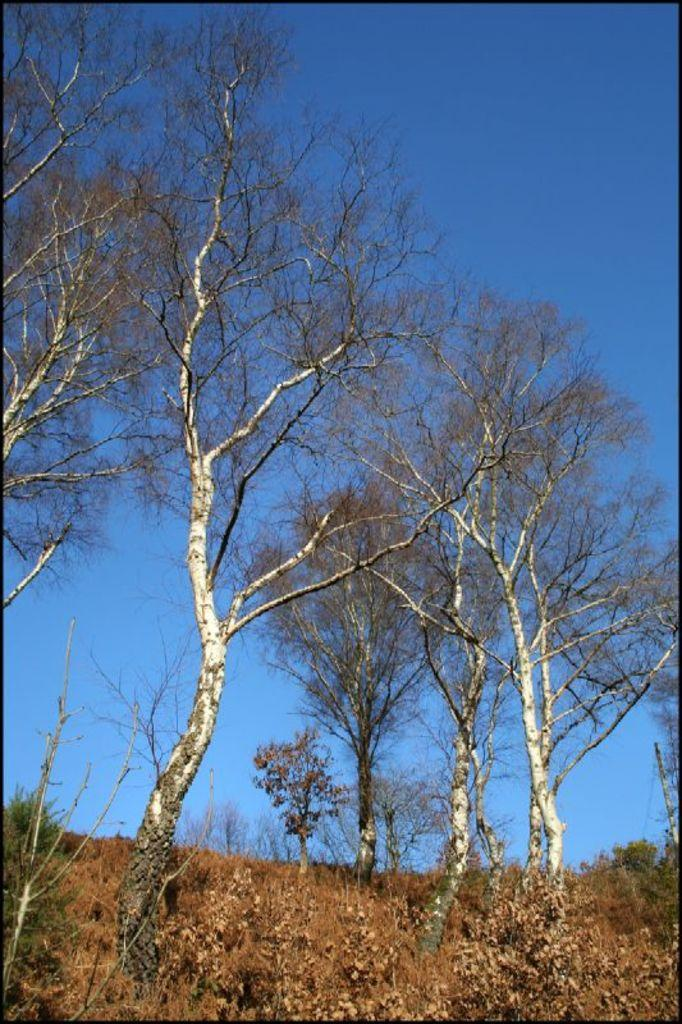What type of vegetation can be seen in the image? There are plants and trees in the image. Can you describe the pole in the image? There is a pole in the image, but no additional details are provided. What is visible in the background of the image? The sky is visible in the background of the image. What type of linen is draped over the tree in the image? There is no linen draped over any tree in the image. How many leaves can be seen on the plants in the image? The provided facts do not specify the number of leaves on the plants in the image. 